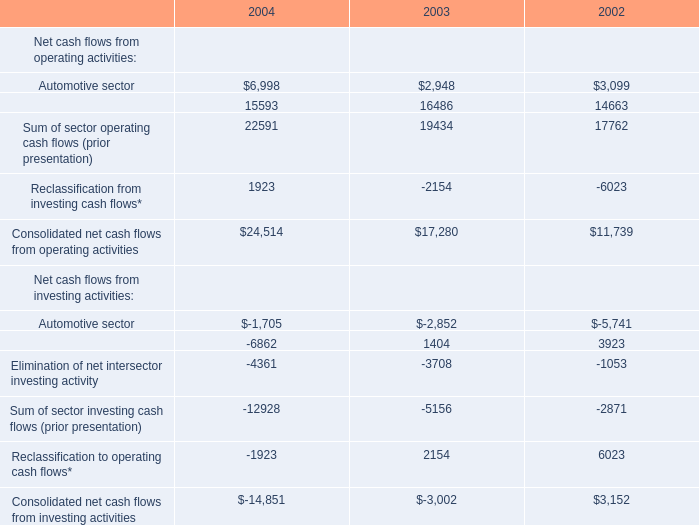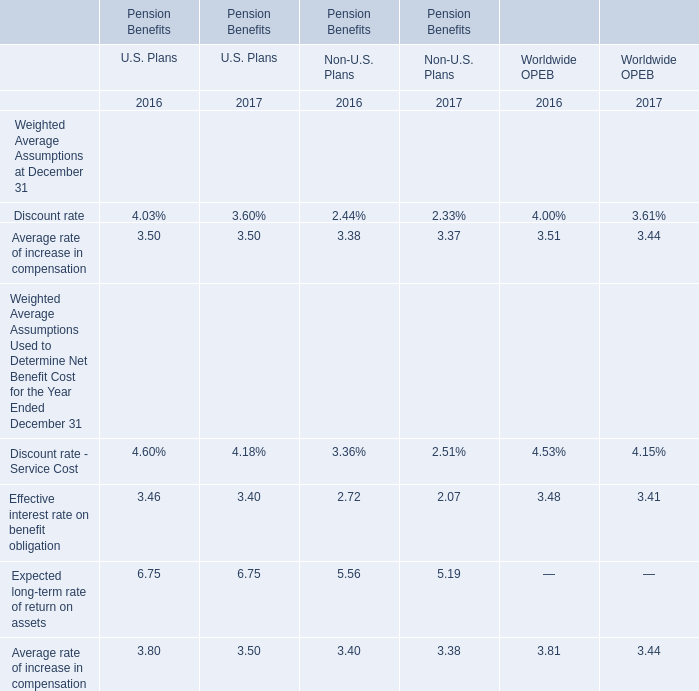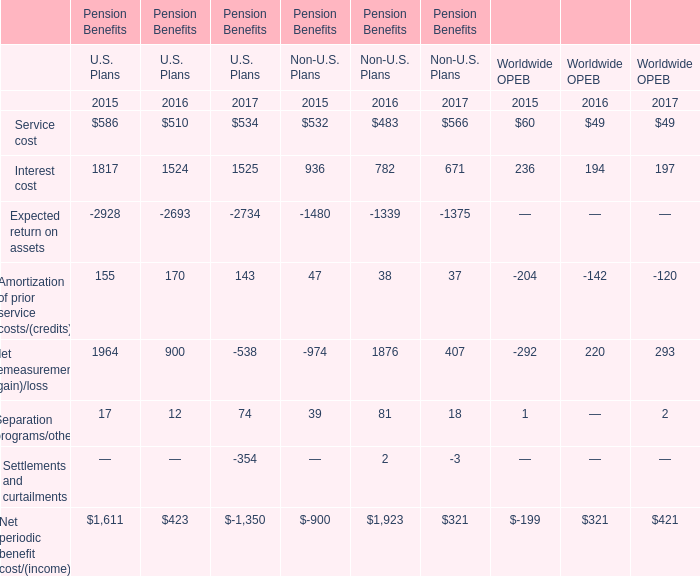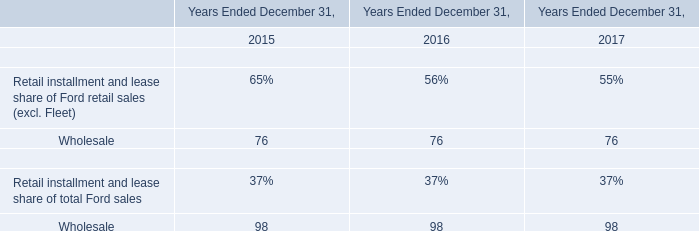In the year with largest amount of Separation programs/other, what's the sum of pension benefit of Non-U.S. Plans ? 
Computations: ((((((483 + 782) - 1339) + 38) + 1876) + 81) + 2)
Answer: 1923.0. 